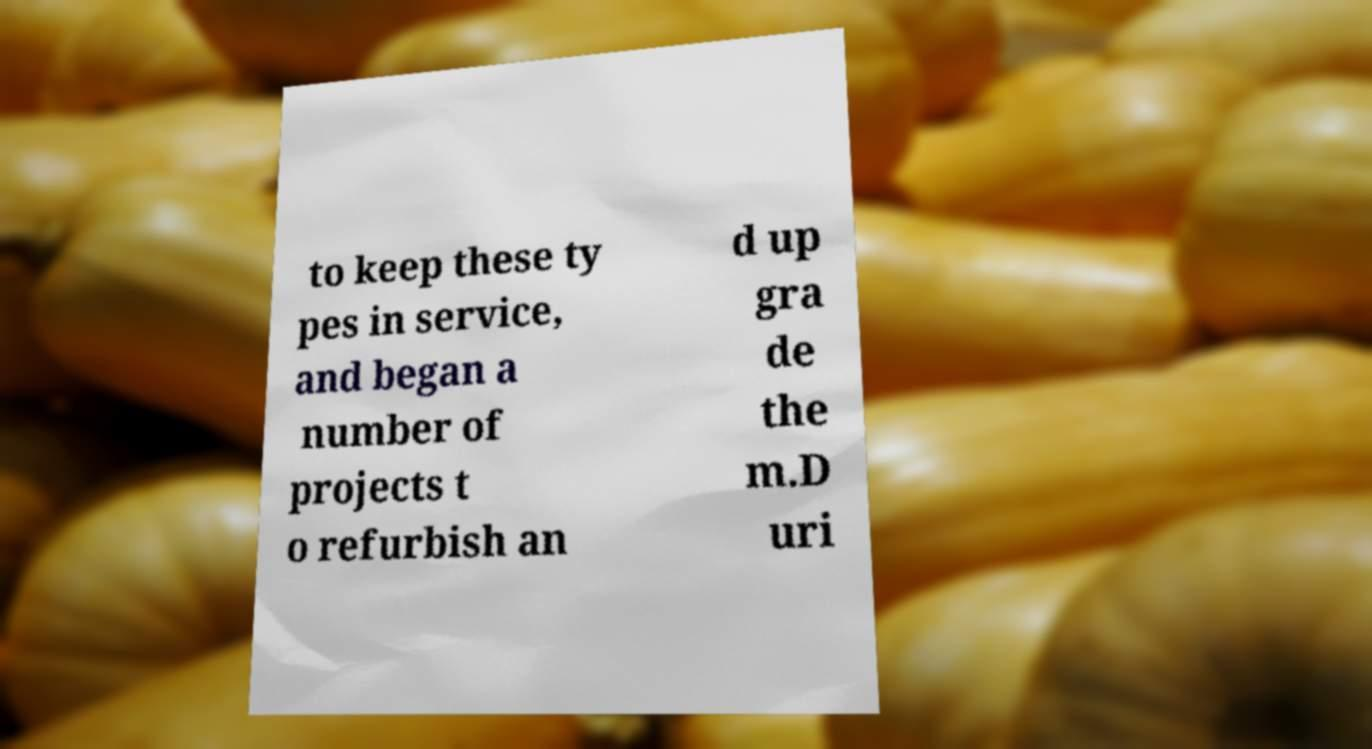I need the written content from this picture converted into text. Can you do that? to keep these ty pes in service, and began a number of projects t o refurbish an d up gra de the m.D uri 